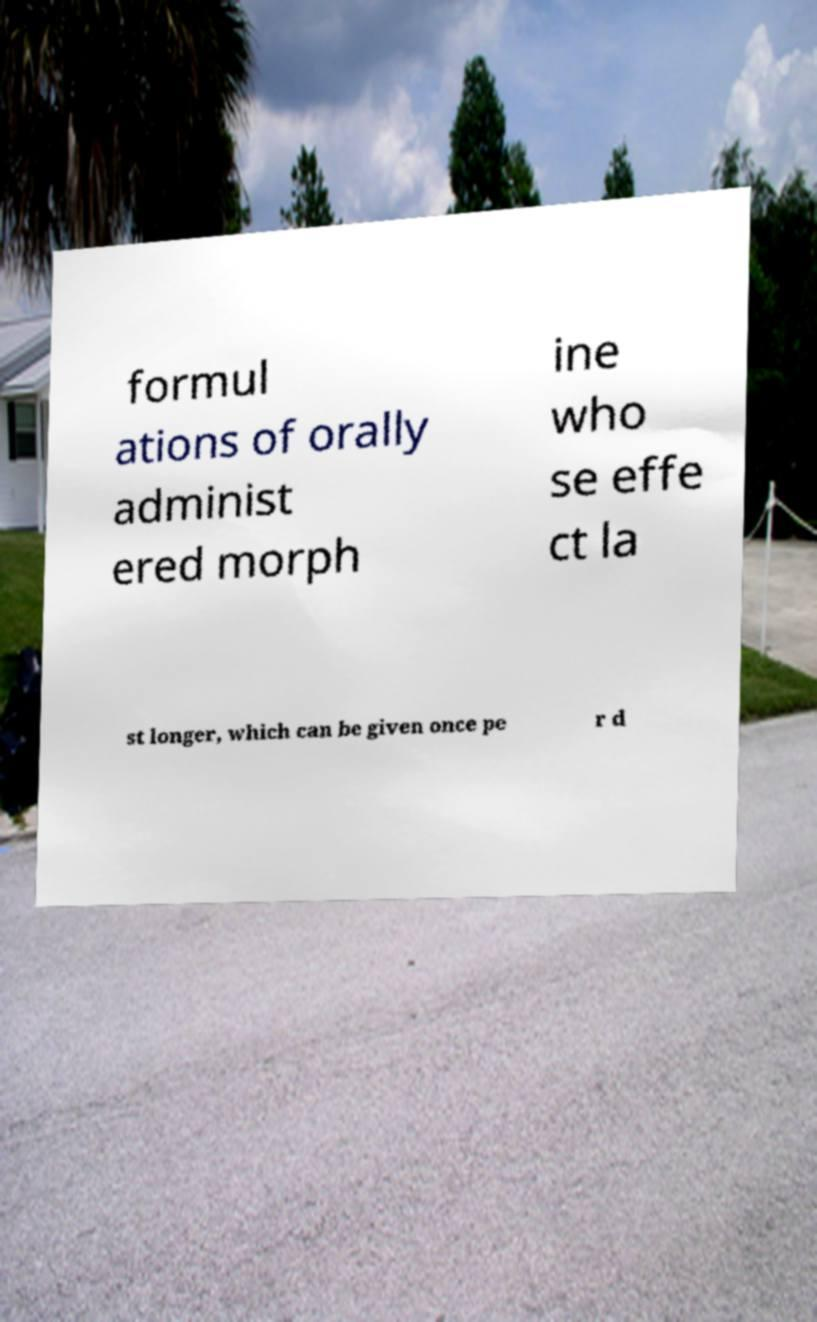What messages or text are displayed in this image? I need them in a readable, typed format. formul ations of orally administ ered morph ine who se effe ct la st longer, which can be given once pe r d 